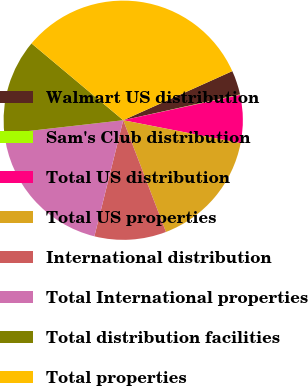<chart> <loc_0><loc_0><loc_500><loc_500><pie_chart><fcel>Walmart US distribution<fcel>Sam's Club distribution<fcel>Total US distribution<fcel>Total US properties<fcel>International distribution<fcel>Total International properties<fcel>Total distribution facilities<fcel>Total properties<nl><fcel>3.27%<fcel>0.06%<fcel>6.48%<fcel>16.11%<fcel>9.69%<fcel>19.32%<fcel>12.9%<fcel>32.17%<nl></chart> 